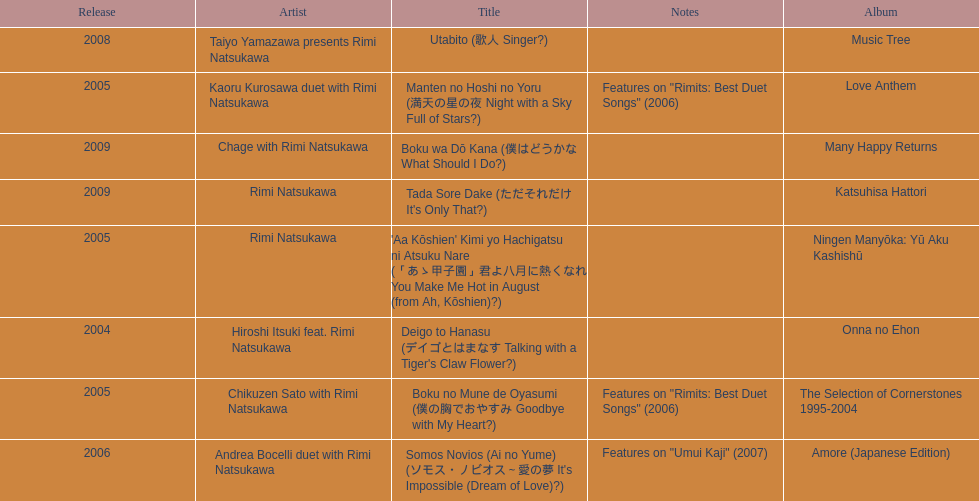Which year had the most titles released? 2005. 